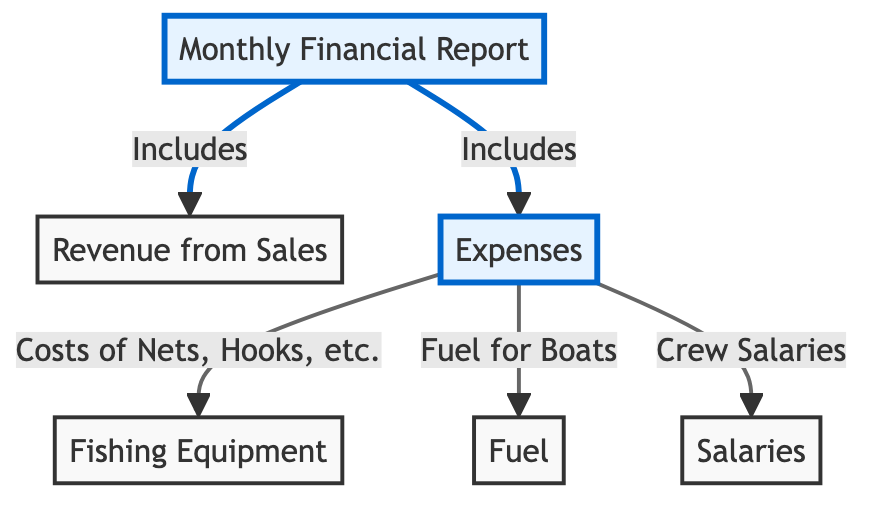What is the main focus of the diagram? The main focus of the diagram is the Monthly Financial Report, which is represented at the top of the diagram as the main node.
Answer: Monthly Financial Report What are the two key components included in the Monthly Financial Report? The diagram clearly shows two components: Revenue from Sales and Expenses. These components stem directly from the Monthly Financial Report node.
Answer: Revenue from Sales, Expenses How many types of expenses are listed in the diagram? There are three types of expenses identified in the diagram: Fishing Equipment, Fuel, and Salaries. This is determined by counting the branching nodes under the Expenses node.
Answer: Three What is the relationship between Revenue and Expenses in the context of this report? Revenue and Expenses are both included components of the Monthly Financial Report, indicating they are both important financial metrics being tracked. The relationship is that they are part of the financial summary.
Answer: Included components Which type of expense does "Nets, Hooks, etc." relate to? "Nets, Hooks, etc." is categorized under Fishing Equipment in the diagram, which is one of the expense types listed. This is indicated by an arrow leading from the Expenses node to Fishing Equipment and then specifying the costs.
Answer: Fishing Equipment If the total revenue is high, what could the Expenses reflect on the financial health? If the total revenue is high, it suggests potential profitability, while the total expenses reflect the costs incurred; thus, if expenses are managed well, it indicates good financial health. This relationship requires evaluating both Revenue and Expenses in tandem.
Answer: Good financial health What does "Crew Salaries" fall under in this financial report? "Crew Salaries" falls under Expenses, as indicated by the directed edge leading from the Expenses node to the Salaries node in the diagram.
Answer: Expenses What does the abbreviation "MFR" stand for in this diagram? The abbreviation "MFR" stands for Monthly Financial Report, as shown in the main node at the top of the diagram.
Answer: Monthly Financial Report 